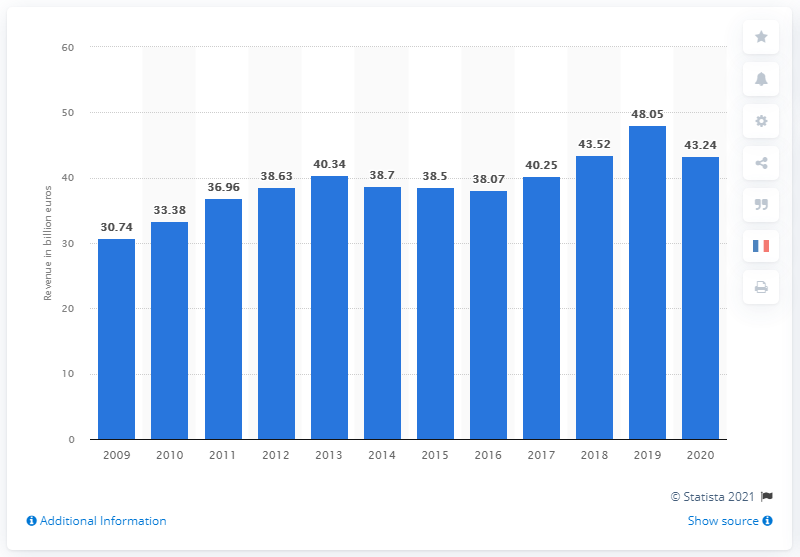Indicate a few pertinent items in this graphic. In 2020, Vinci generated a revenue of 43.24.. 